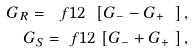Convert formula to latex. <formula><loc_0><loc_0><loc_500><loc_500>G _ { R } = \ f { 1 } { 2 } \ [ G _ { - } - G _ { + } \ ] \, , \\ G _ { S } = \ f { 1 } { 2 } \ [ G _ { - } + G _ { + } \ ] \, ,</formula> 